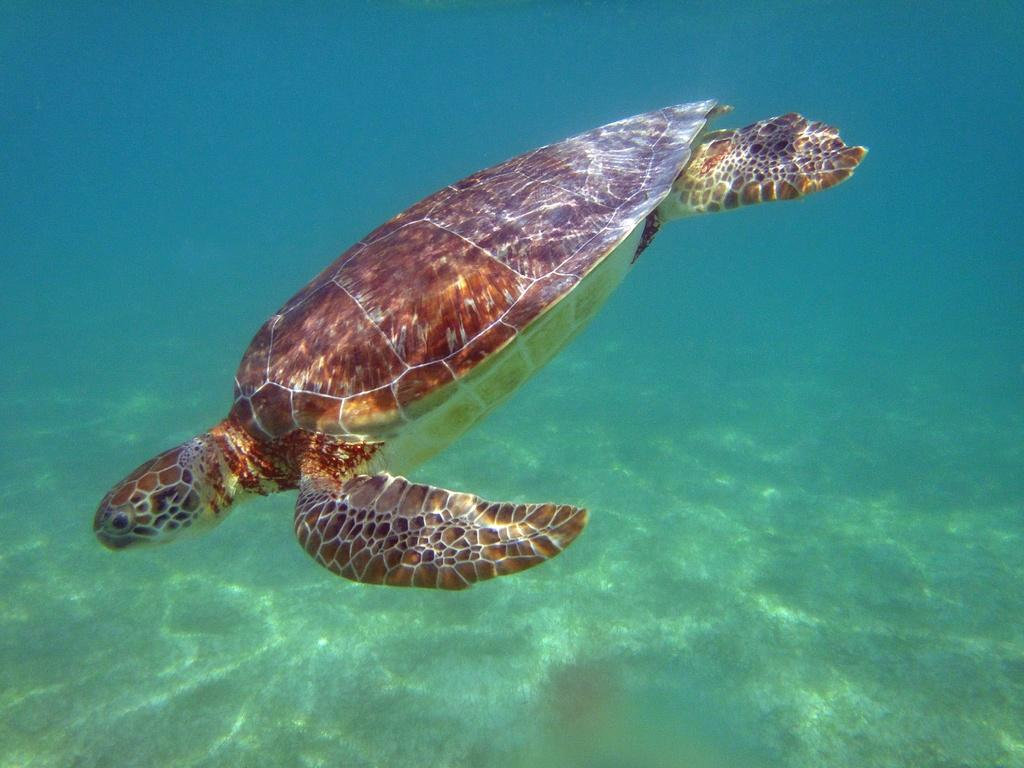What type of environment is depicted in the image? The image is an underwater scene. What animal can be seen in the image? There is a tortoise in the image. What colors are present on the tortoise? The tortoise is brown, black, and cream in color. What is visible in the background of the image? The sky is visible in the background of the image. What type of flower is blooming in the image? There are no flowers present in the underwater scene depicted in the image. 